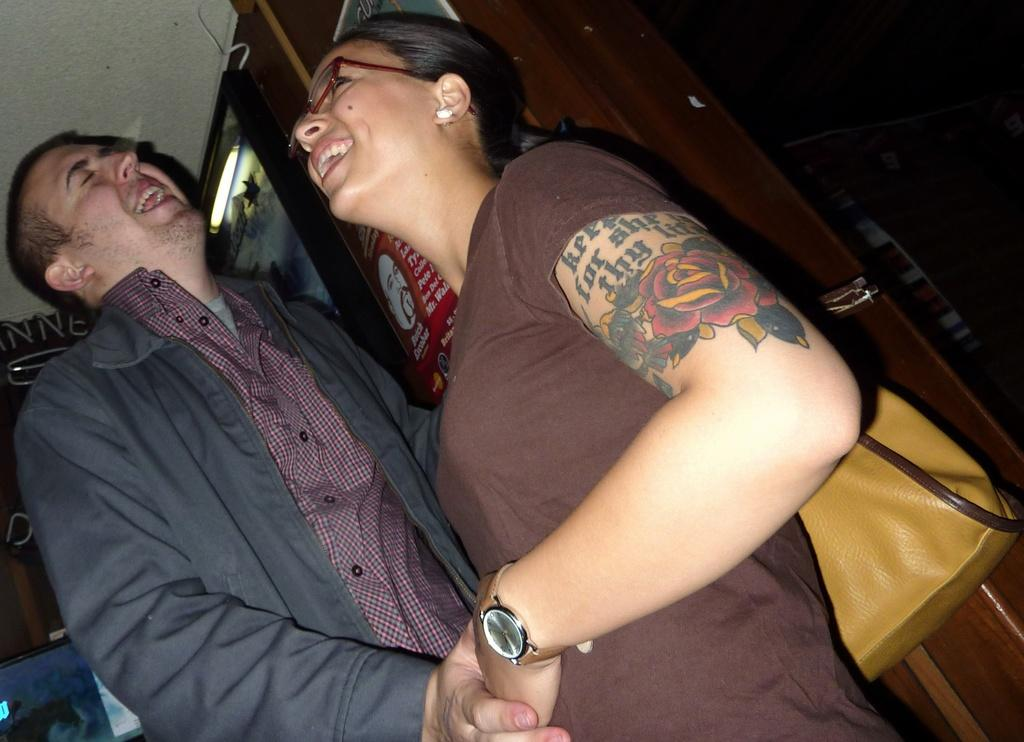How many people are in the image? There are two persons standing in the image. What is the woman wearing in the image? The woman is wearing a brown color bag. What is the man wearing in the image? The man is wearing a coat. What is the facial expression of the people in the image? The people are smiling. What can be seen in the background of the image? There is a cupboard visible in the background, along with other objects. What type of crack can be seen on the edge of the cupboard in the image? There is no crack visible on the edge of the cupboard in the image. 